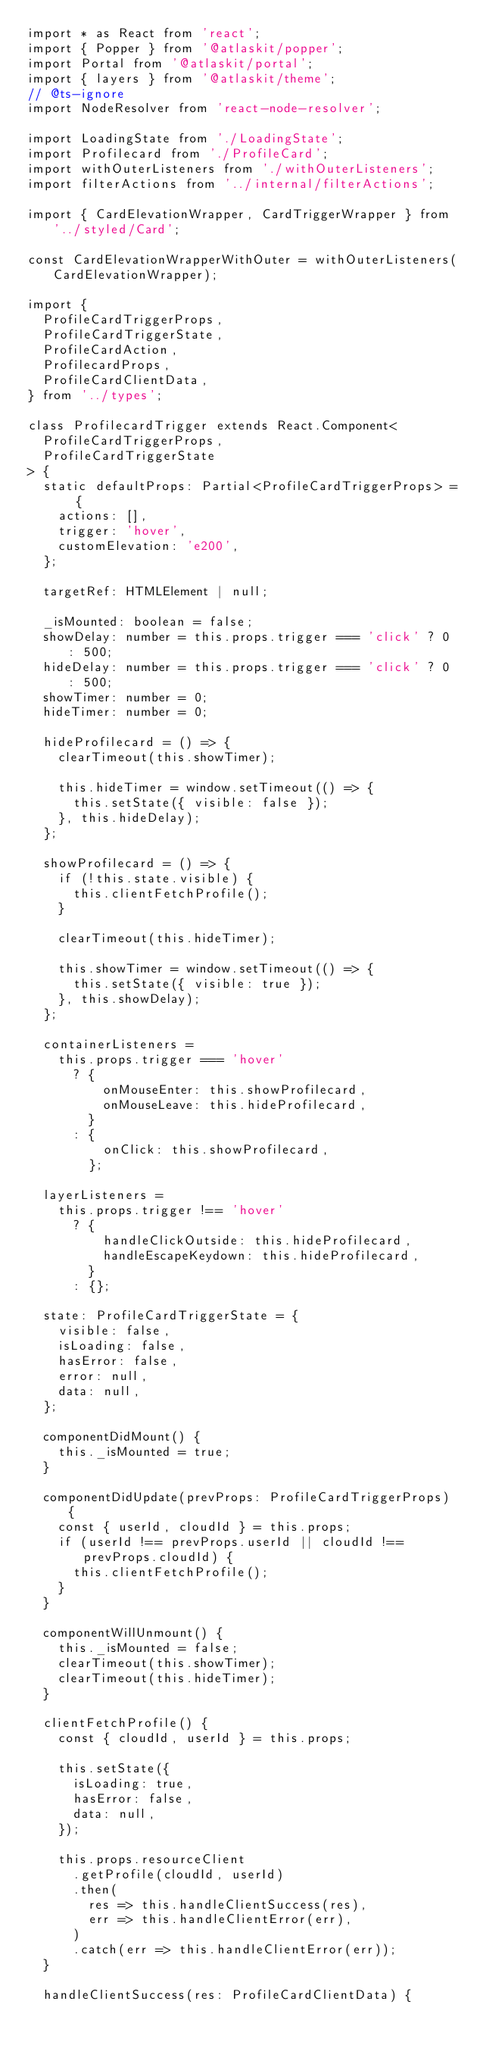Convert code to text. <code><loc_0><loc_0><loc_500><loc_500><_TypeScript_>import * as React from 'react';
import { Popper } from '@atlaskit/popper';
import Portal from '@atlaskit/portal';
import { layers } from '@atlaskit/theme';
// @ts-ignore
import NodeResolver from 'react-node-resolver';

import LoadingState from './LoadingState';
import Profilecard from './ProfileCard';
import withOuterListeners from './withOuterListeners';
import filterActions from '../internal/filterActions';

import { CardElevationWrapper, CardTriggerWrapper } from '../styled/Card';

const CardElevationWrapperWithOuter = withOuterListeners(CardElevationWrapper);

import {
  ProfileCardTriggerProps,
  ProfileCardTriggerState,
  ProfileCardAction,
  ProfilecardProps,
  ProfileCardClientData,
} from '../types';

class ProfilecardTrigger extends React.Component<
  ProfileCardTriggerProps,
  ProfileCardTriggerState
> {
  static defaultProps: Partial<ProfileCardTriggerProps> = {
    actions: [],
    trigger: 'hover',
    customElevation: 'e200',
  };

  targetRef: HTMLElement | null;

  _isMounted: boolean = false;
  showDelay: number = this.props.trigger === 'click' ? 0 : 500;
  hideDelay: number = this.props.trigger === 'click' ? 0 : 500;
  showTimer: number = 0;
  hideTimer: number = 0;

  hideProfilecard = () => {
    clearTimeout(this.showTimer);

    this.hideTimer = window.setTimeout(() => {
      this.setState({ visible: false });
    }, this.hideDelay);
  };

  showProfilecard = () => {
    if (!this.state.visible) {
      this.clientFetchProfile();
    }

    clearTimeout(this.hideTimer);

    this.showTimer = window.setTimeout(() => {
      this.setState({ visible: true });
    }, this.showDelay);
  };

  containerListeners =
    this.props.trigger === 'hover'
      ? {
          onMouseEnter: this.showProfilecard,
          onMouseLeave: this.hideProfilecard,
        }
      : {
          onClick: this.showProfilecard,
        };

  layerListeners =
    this.props.trigger !== 'hover'
      ? {
          handleClickOutside: this.hideProfilecard,
          handleEscapeKeydown: this.hideProfilecard,
        }
      : {};

  state: ProfileCardTriggerState = {
    visible: false,
    isLoading: false,
    hasError: false,
    error: null,
    data: null,
  };

  componentDidMount() {
    this._isMounted = true;
  }

  componentDidUpdate(prevProps: ProfileCardTriggerProps) {
    const { userId, cloudId } = this.props;
    if (userId !== prevProps.userId || cloudId !== prevProps.cloudId) {
      this.clientFetchProfile();
    }
  }

  componentWillUnmount() {
    this._isMounted = false;
    clearTimeout(this.showTimer);
    clearTimeout(this.hideTimer);
  }

  clientFetchProfile() {
    const { cloudId, userId } = this.props;

    this.setState({
      isLoading: true,
      hasError: false,
      data: null,
    });

    this.props.resourceClient
      .getProfile(cloudId, userId)
      .then(
        res => this.handleClientSuccess(res),
        err => this.handleClientError(err),
      )
      .catch(err => this.handleClientError(err));
  }

  handleClientSuccess(res: ProfileCardClientData) {</code> 